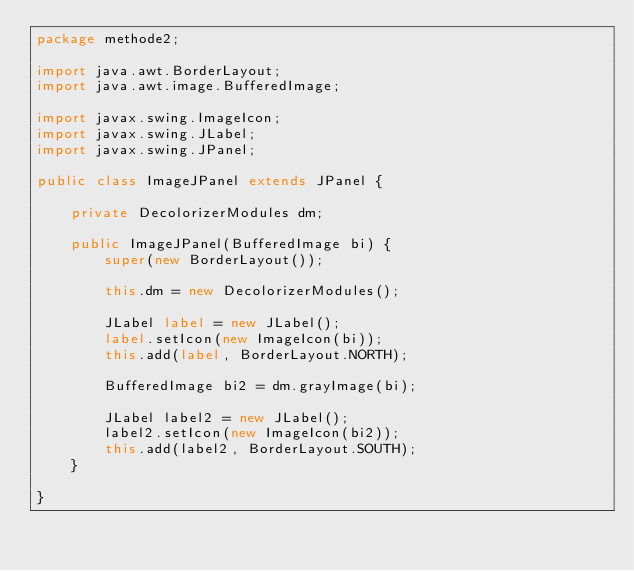Convert code to text. <code><loc_0><loc_0><loc_500><loc_500><_Java_>package methode2;

import java.awt.BorderLayout;
import java.awt.image.BufferedImage;

import javax.swing.ImageIcon;
import javax.swing.JLabel;
import javax.swing.JPanel;

public class ImageJPanel extends JPanel {
	
	private DecolorizerModules dm;
	
	public ImageJPanel(BufferedImage bi) {
		super(new BorderLayout());		
		
		this.dm = new DecolorizerModules();
		
		JLabel label = new JLabel();
		label.setIcon(new ImageIcon(bi));
		this.add(label, BorderLayout.NORTH);
		
		BufferedImage bi2 = dm.grayImage(bi);
		
		JLabel label2 = new JLabel();
		label2.setIcon(new ImageIcon(bi2));
		this.add(label2, BorderLayout.SOUTH);
	}

}
</code> 